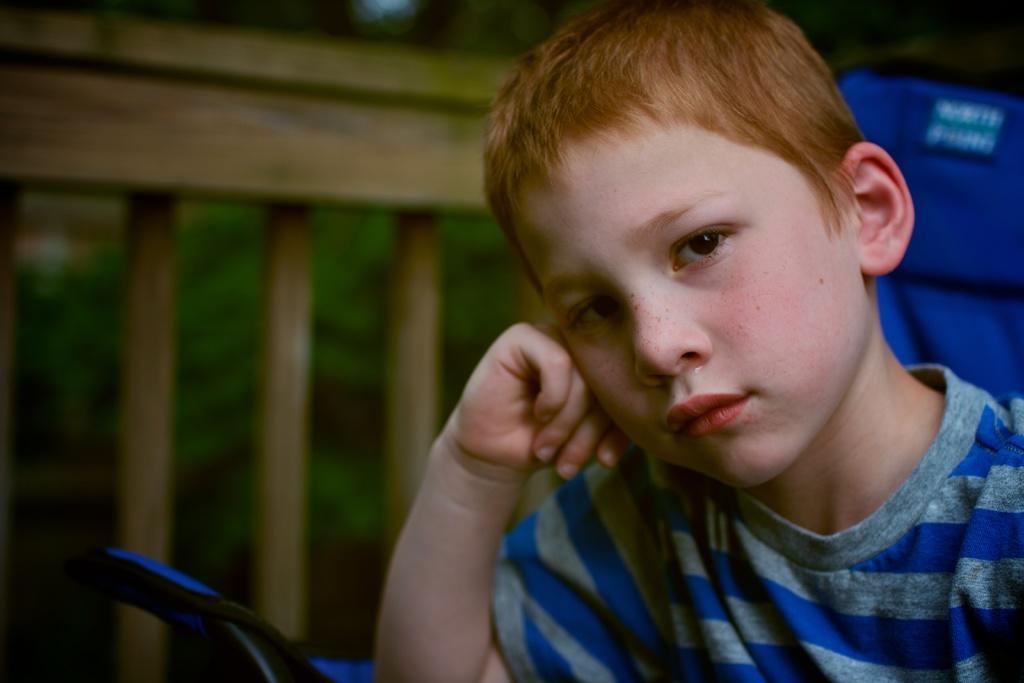How would you summarize this image in a sentence or two? In this image we can see a boy, fence and an object, and also the background is blurred. 